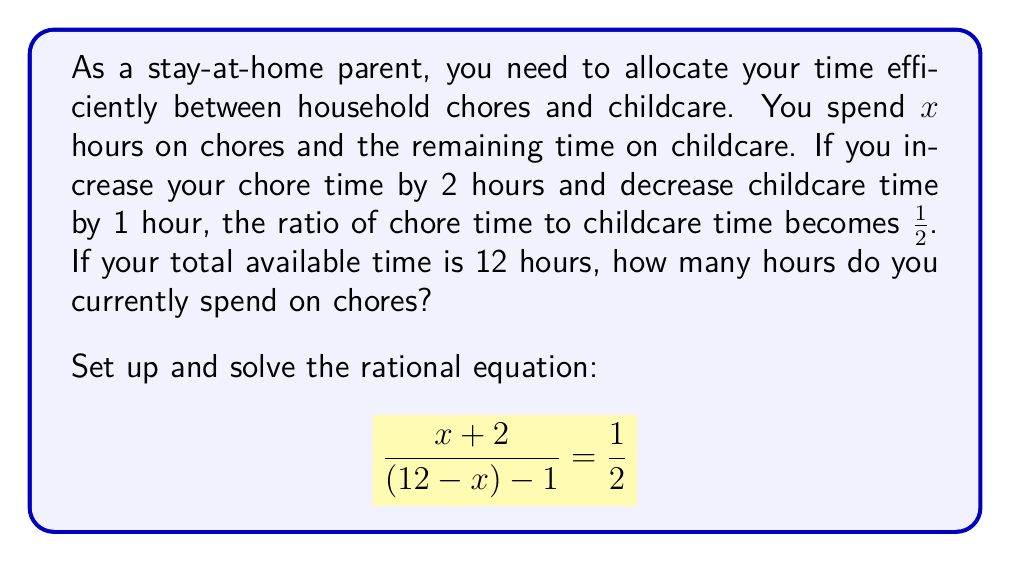Provide a solution to this math problem. Let's solve this step-by-step:

1) First, let's set up the equation:
   $$\frac{x+2}{(12-x)-1} = \frac{1}{2}$$

2) Simplify the denominator:
   $$\frac{x+2}{11-x} = \frac{1}{2}$$

3) Cross multiply:
   $2(x+2) = 11-x$

4) Distribute on the left side:
   $2x + 4 = 11-x$

5) Add $x$ to both sides:
   $3x + 4 = 11$

6) Subtract 4 from both sides:
   $3x = 7$

7) Divide both sides by 3:
   $x = \frac{7}{3}$

8) This is approximately 2.33 hours, which we can round to 2 hours and 20 minutes.

We can verify this solution:
- Current time spent on chores: $\frac{7}{3}$ hours
- Current time spent on childcare: $12 - \frac{7}{3} = \frac{29}{3}$ hours
- If we add 2 hours to chores and subtract 1 hour from childcare:
  $$\frac{\frac{7}{3} + 2}{\frac{29}{3} - 1} = \frac{\frac{13}{3}}{\frac{26}{3}} = \frac{1}{2}$$

This confirms our solution is correct.
Answer: $\frac{7}{3}$ hours (or 2 hours and 20 minutes) 